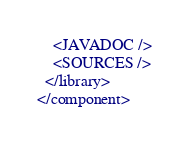<code> <loc_0><loc_0><loc_500><loc_500><_XML_>    <JAVADOC />
    <SOURCES />
  </library>
</component></code> 